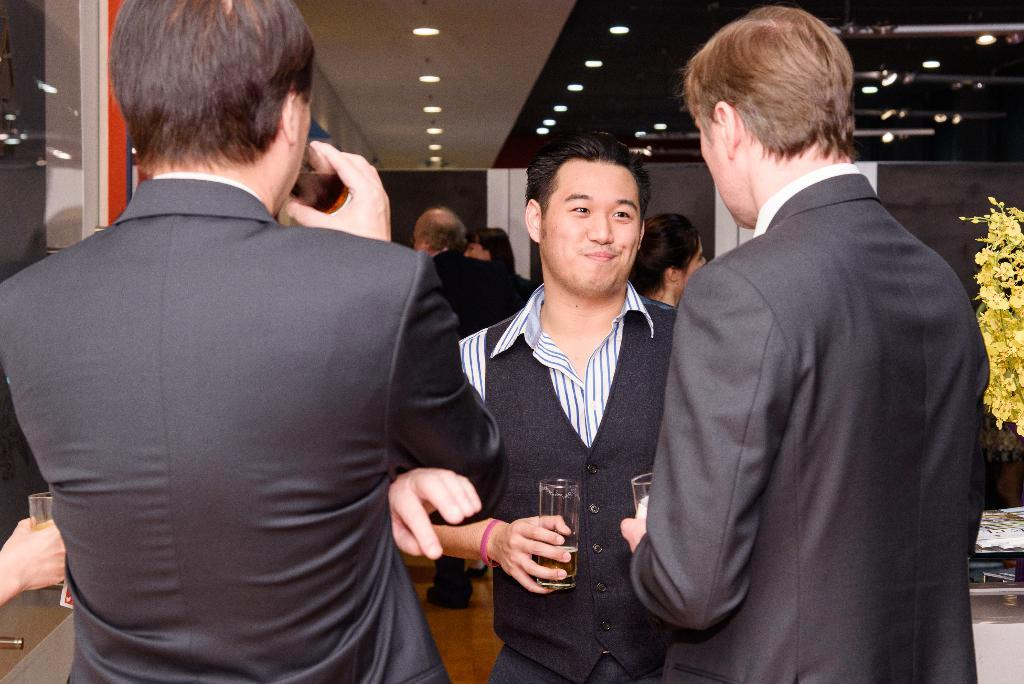How many people are in the image? There is a group of people in the image. What are the people wearing in the image? The people are wearing coats in the image. What are the people doing in the image? The people are standing in the image. Can you describe the person holding an object in the image? One person is holding a glass in his hand in the image. What can be seen in the background of the image? There is a plant and lights visible in the background of the image. What type of rose is the person holding in the image? There is no rose present in the image; one person is holding a glass. How does the person feel about their recent loss in the image? There is no indication of any loss or emotional state in the image; it only shows a group of people standing and wearing coats. 